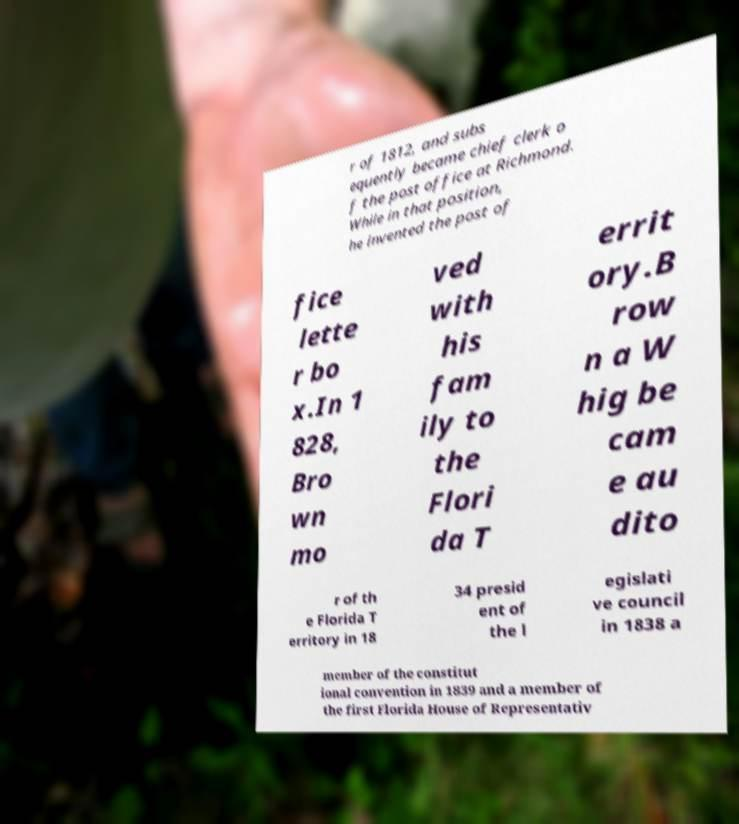Can you accurately transcribe the text from the provided image for me? r of 1812, and subs equently became chief clerk o f the post office at Richmond. While in that position, he invented the post of fice lette r bo x.In 1 828, Bro wn mo ved with his fam ily to the Flori da T errit ory.B row n a W hig be cam e au dito r of th e Florida T erritory in 18 34 presid ent of the l egislati ve council in 1838 a member of the constitut ional convention in 1839 and a member of the first Florida House of Representativ 